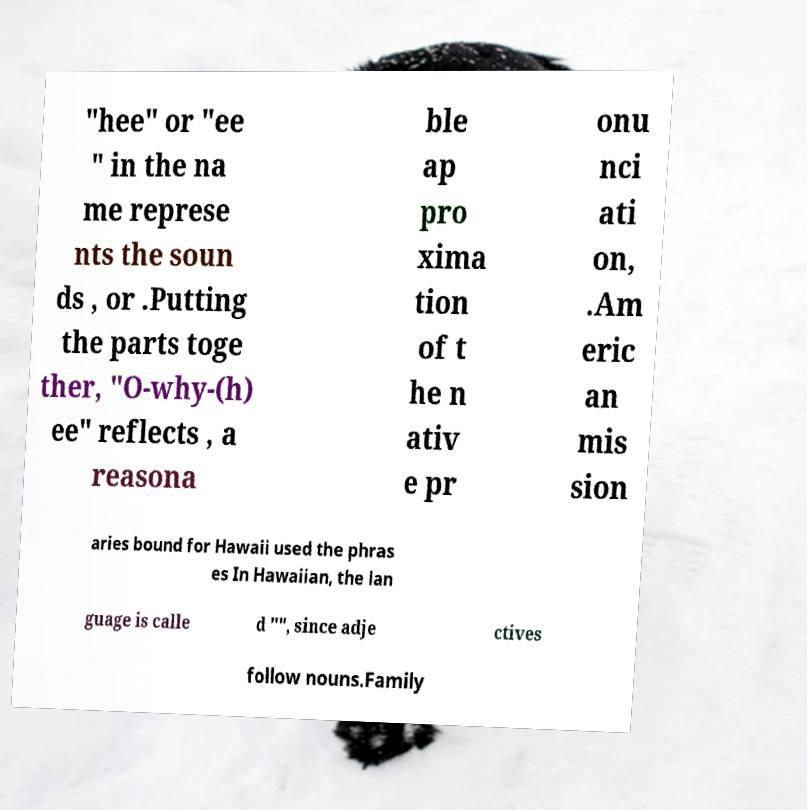Please identify and transcribe the text found in this image. "hee" or "ee " in the na me represe nts the soun ds , or .Putting the parts toge ther, "O-why-(h) ee" reflects , a reasona ble ap pro xima tion of t he n ativ e pr onu nci ati on, .Am eric an mis sion aries bound for Hawaii used the phras es In Hawaiian, the lan guage is calle d "", since adje ctives follow nouns.Family 